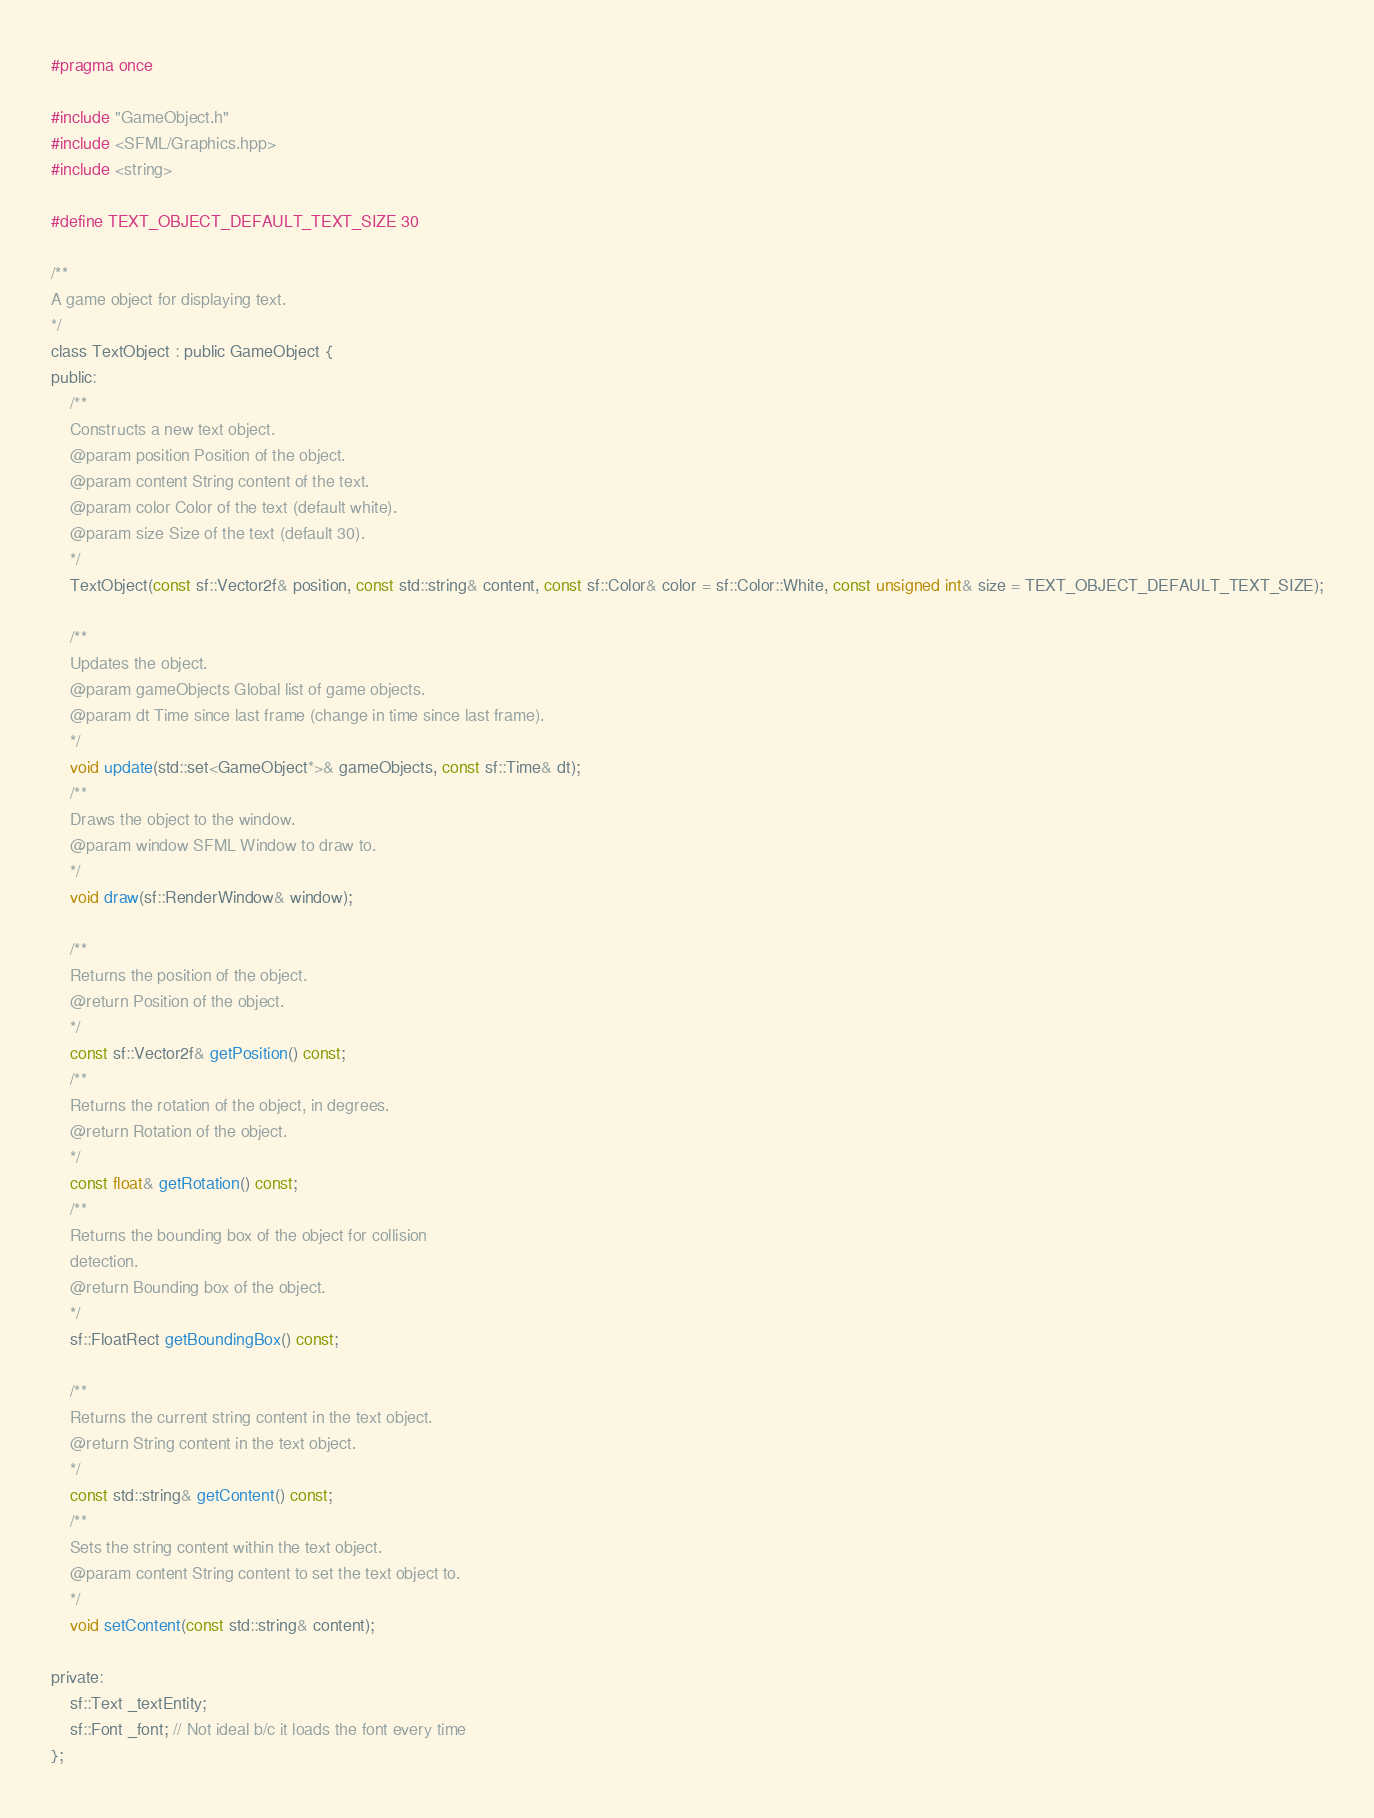Convert code to text. <code><loc_0><loc_0><loc_500><loc_500><_C_>#pragma once

#include "GameObject.h"
#include <SFML/Graphics.hpp>
#include <string>

#define TEXT_OBJECT_DEFAULT_TEXT_SIZE 30

/**
A game object for displaying text.
*/
class TextObject : public GameObject {
public:
	/**
	Constructs a new text object.
	@param position Position of the object.
	@param content String content of the text.
	@param color Color of the text (default white).
	@param size Size of the text (default 30).
	*/
	TextObject(const sf::Vector2f& position, const std::string& content, const sf::Color& color = sf::Color::White, const unsigned int& size = TEXT_OBJECT_DEFAULT_TEXT_SIZE);

	/**
	Updates the object.
	@param gameObjects Global list of game objects.
	@param dt Time since last frame (change in time since last frame).
	*/
	void update(std::set<GameObject*>& gameObjects, const sf::Time& dt);
	/**
	Draws the object to the window.
	@param window SFML Window to draw to.
	*/
	void draw(sf::RenderWindow& window);

	/**
	Returns the position of the object.
	@return Position of the object.
	*/
	const sf::Vector2f& getPosition() const;
	/**
	Returns the rotation of the object, in degrees.
	@return Rotation of the object.
	*/
	const float& getRotation() const;
	/**
	Returns the bounding box of the object for collision
	detection.
	@return Bounding box of the object.
	*/
	sf::FloatRect getBoundingBox() const;

	/**
	Returns the current string content in the text object.
	@return String content in the text object.
	*/
	const std::string& getContent() const;
	/**
	Sets the string content within the text object.
	@param content String content to set the text object to.
	*/
	void setContent(const std::string& content);

private:
	sf::Text _textEntity;
	sf::Font _font; // Not ideal b/c it loads the font every time
};</code> 